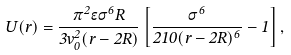Convert formula to latex. <formula><loc_0><loc_0><loc_500><loc_500>U ( r ) = \frac { \pi ^ { 2 } \epsilon \sigma ^ { 6 } R } { 3 v _ { 0 } ^ { 2 } ( r - 2 R ) } \left [ \frac { \sigma ^ { 6 } } { 2 1 0 ( r - 2 R ) ^ { 6 } } - 1 \right ] ,</formula> 